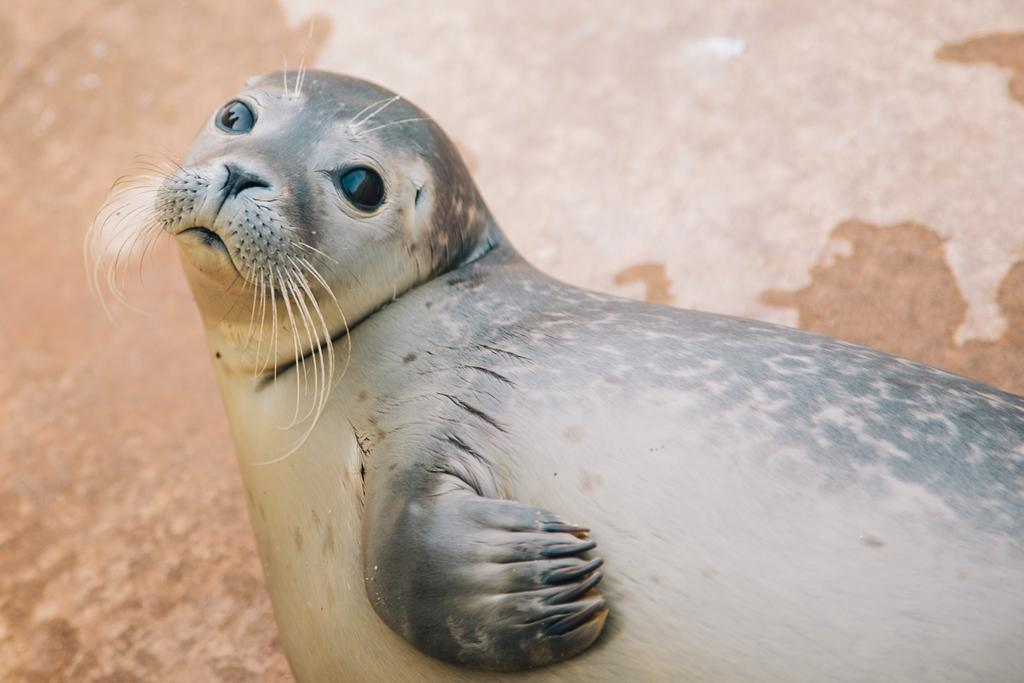What animal is present in the image? There is a seal in the image. Where is the seal located in the image? The seal is on the ground. What type of acoustics can be heard from the seal in the image? There is no indication of any sound or acoustics in the image, as it only shows a seal on the ground. 